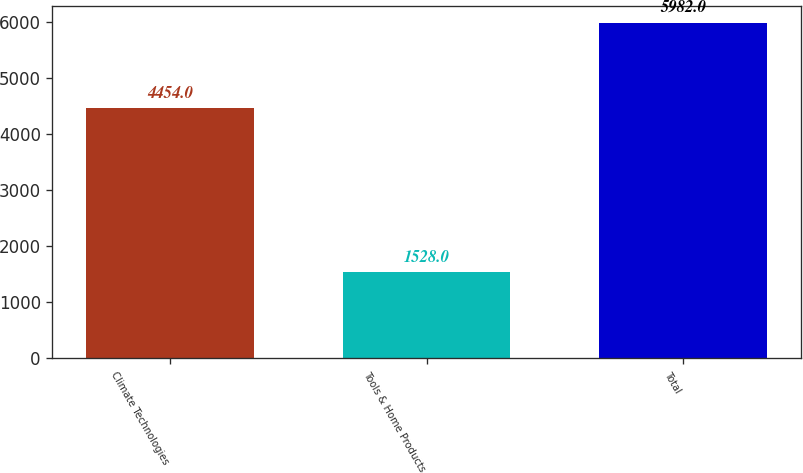Convert chart to OTSL. <chart><loc_0><loc_0><loc_500><loc_500><bar_chart><fcel>Climate Technologies<fcel>Tools & Home Products<fcel>Total<nl><fcel>4454<fcel>1528<fcel>5982<nl></chart> 